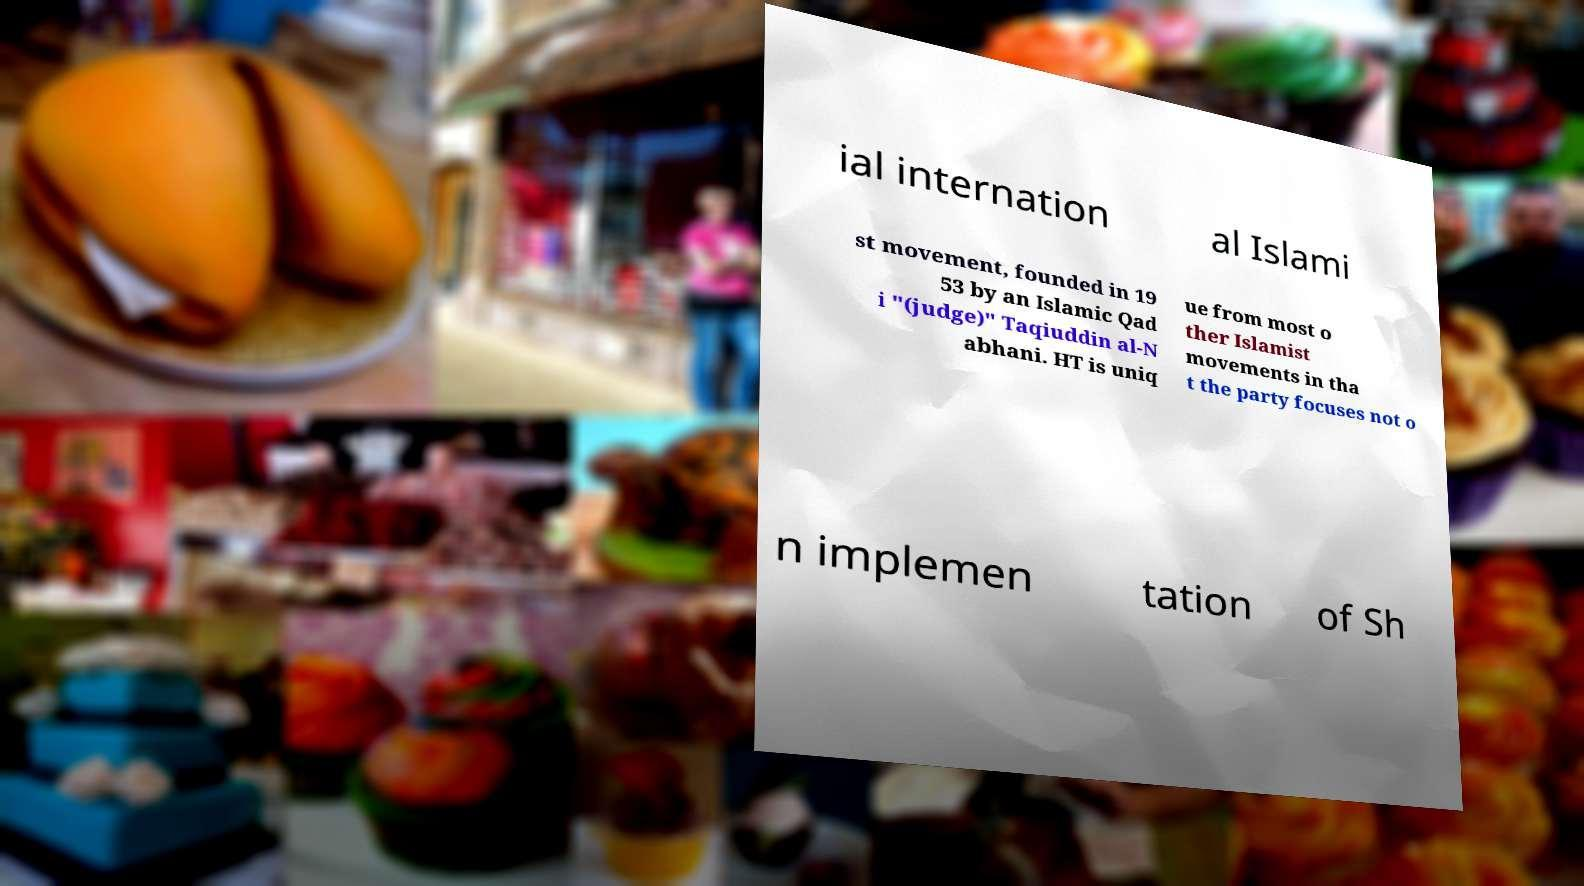Could you assist in decoding the text presented in this image and type it out clearly? ial internation al Islami st movement, founded in 19 53 by an Islamic Qad i "(judge)" Taqiuddin al-N abhani. HT is uniq ue from most o ther Islamist movements in tha t the party focuses not o n implemen tation of Sh 